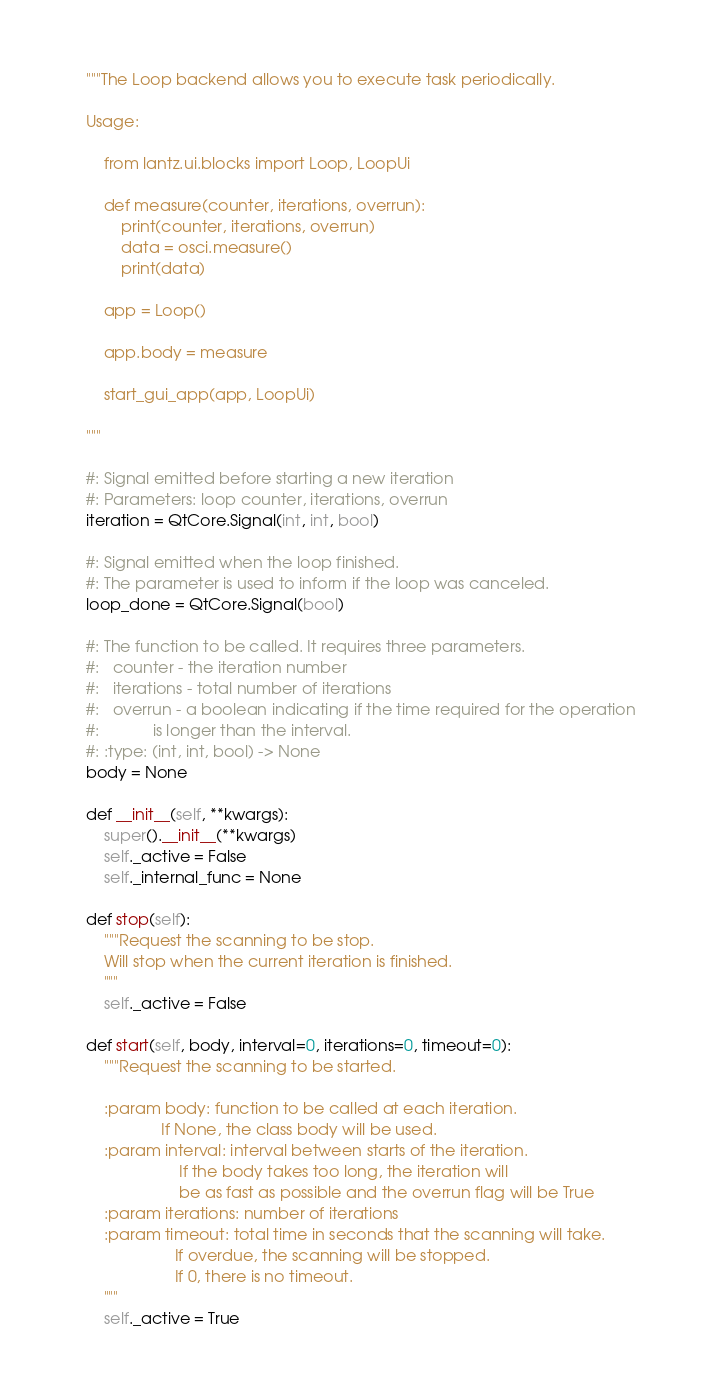Convert code to text. <code><loc_0><loc_0><loc_500><loc_500><_Python_>    """The Loop backend allows you to execute task periodically.

    Usage:

        from lantz.ui.blocks import Loop, LoopUi

        def measure(counter, iterations, overrun):
            print(counter, iterations, overrun)
            data = osci.measure()
            print(data)

        app = Loop()

        app.body = measure

        start_gui_app(app, LoopUi)

    """

    #: Signal emitted before starting a new iteration
    #: Parameters: loop counter, iterations, overrun
    iteration = QtCore.Signal(int, int, bool)

    #: Signal emitted when the loop finished.
    #: The parameter is used to inform if the loop was canceled.
    loop_done = QtCore.Signal(bool)

    #: The function to be called. It requires three parameters.
    #:   counter - the iteration number
    #:   iterations - total number of iterations
    #:   overrun - a boolean indicating if the time required for the operation
    #:            is longer than the interval.
    #: :type: (int, int, bool) -> None
    body = None

    def __init__(self, **kwargs):
        super().__init__(**kwargs)
        self._active = False
        self._internal_func = None

    def stop(self):
        """Request the scanning to be stop.
        Will stop when the current iteration is finished.
        """
        self._active = False

    def start(self, body, interval=0, iterations=0, timeout=0):
        """Request the scanning to be started.

        :param body: function to be called at each iteration.
                     If None, the class body will be used.
        :param interval: interval between starts of the iteration.
                         If the body takes too long, the iteration will
                         be as fast as possible and the overrun flag will be True
        :param iterations: number of iterations
        :param timeout: total time in seconds that the scanning will take.
                        If overdue, the scanning will be stopped.
                        If 0, there is no timeout.
        """
        self._active = True</code> 